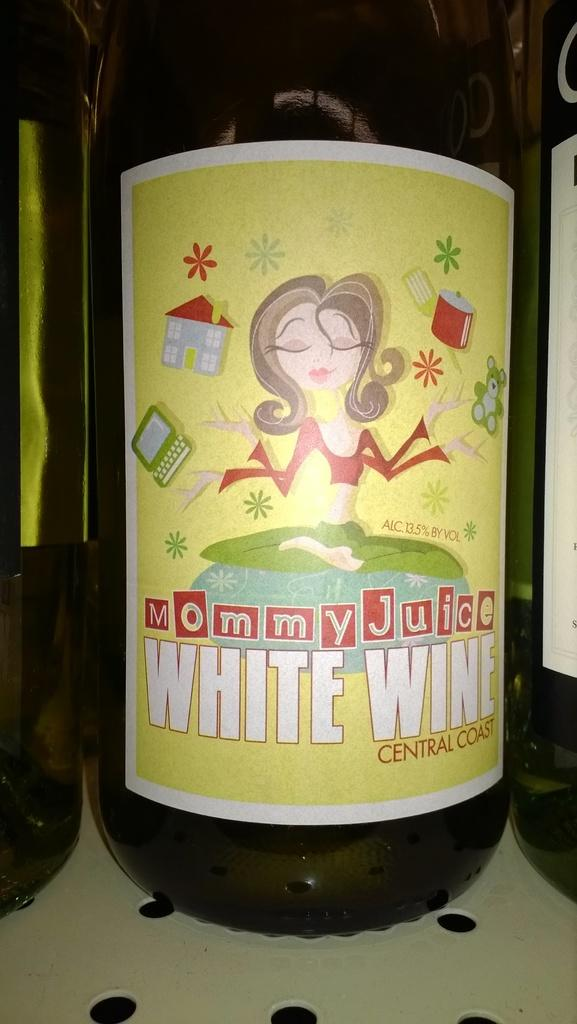<image>
Create a compact narrative representing the image presented. A bottle of Mommy Juice branded white wine wit ha yellow tag. 